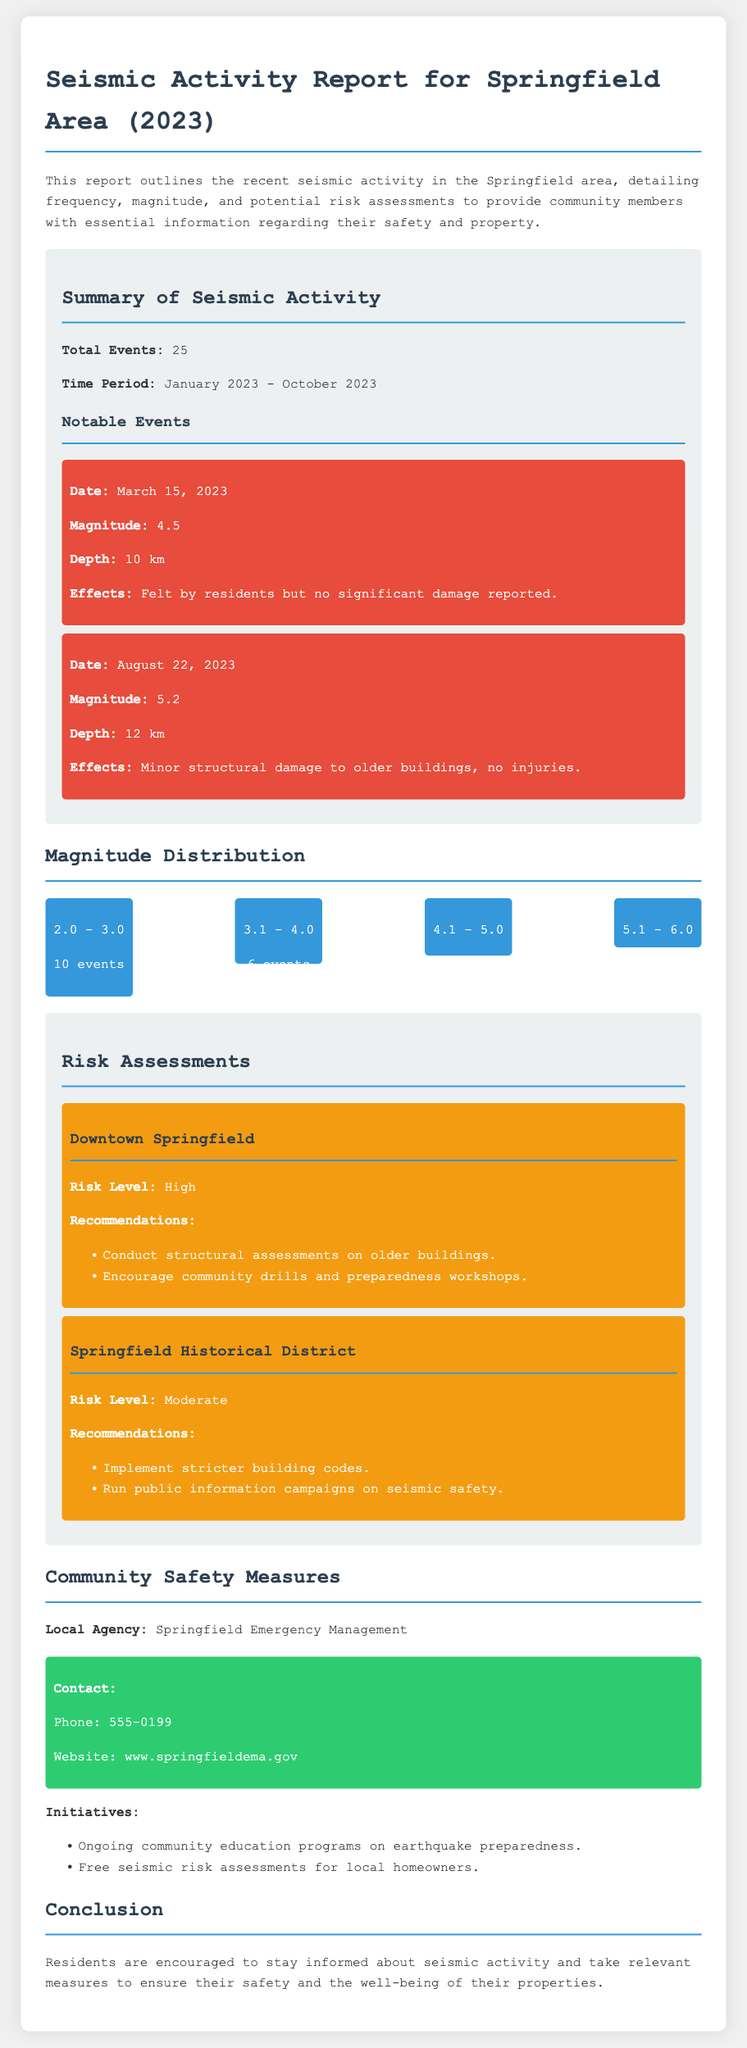What is the total number of seismic events reported? The total number of seismic events is stated in the summary section of the document.
Answer: 25 What was the magnitude of the earthquake on August 22, 2023? The specific earthquake's magnitude can be found in the notable events section detailing each event's information.
Answer: 5.2 Which area has a high risk assessment? The document identifies different areas and their risk levels, including one with a high risk.
Answer: Downtown Springfield What is the depth of the notable event on March 15, 2023? The depth information for that event is explicitly mentioned in the details of that particular notable event.
Answer: 10 km What safety initiative is provided for local homeowners? The document lists specific initiatives offered to residents for their safety and preparedness.
Answer: Free seismic risk assessments What recommendations are made for the Springfield Historical District? Recommendations for various risk areas are outlined in the risk assessments section, specifically for this district.
Answer: Stricter building codes How many events fell within the magnitude range of 2.0 - 3.0? The magnitude distribution section provides a breakdown of events by magnitude ranges, indicating how many events fall into each range.
Answer: 10 events What is the contact number for the Springfield Emergency Management? The contact information is provided in the community safety measures section, specifically the phone number for management.
Answer: 555-0199 